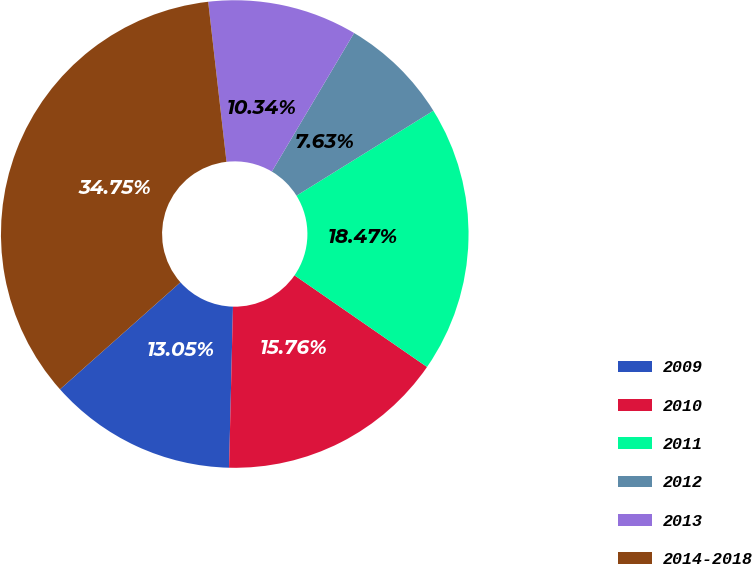Convert chart. <chart><loc_0><loc_0><loc_500><loc_500><pie_chart><fcel>2009<fcel>2010<fcel>2011<fcel>2012<fcel>2013<fcel>2014-2018<nl><fcel>13.05%<fcel>15.76%<fcel>18.47%<fcel>7.63%<fcel>10.34%<fcel>34.75%<nl></chart> 